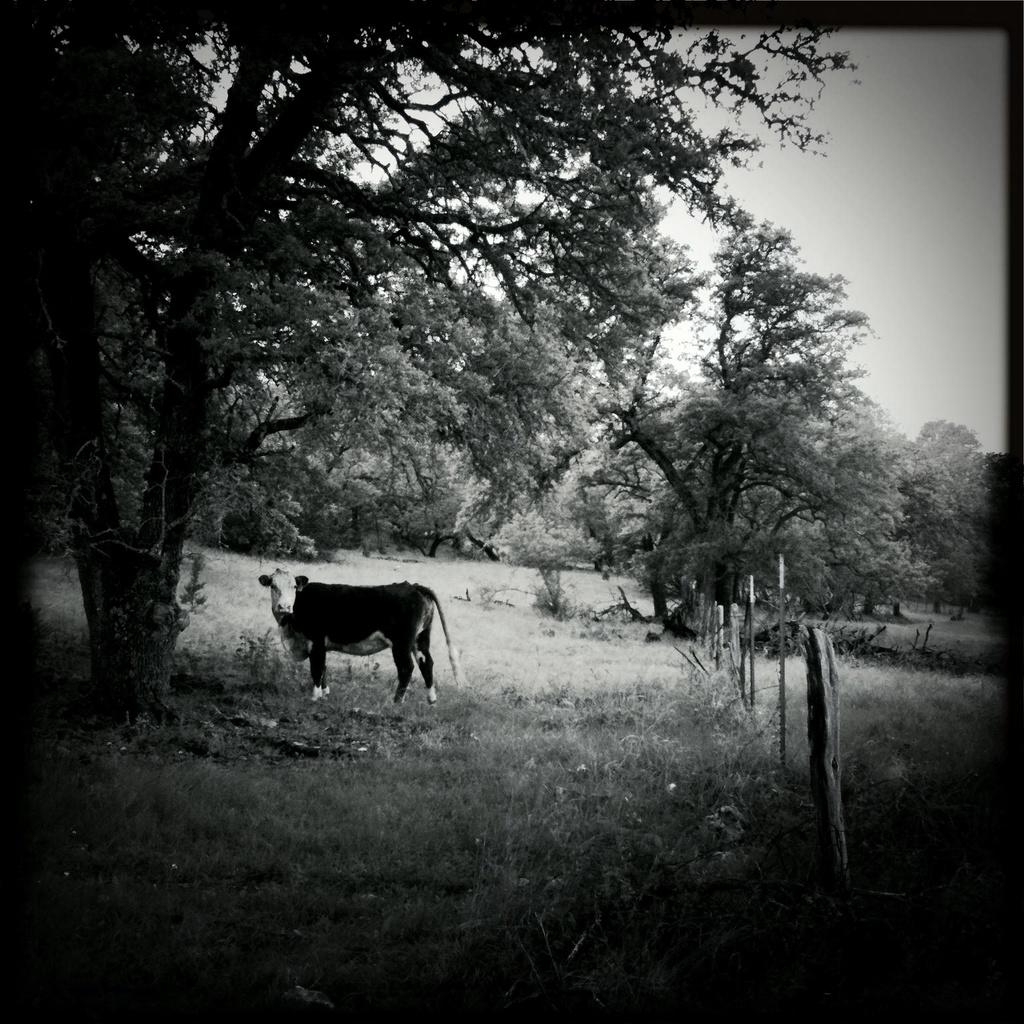What is the main subject in the center of the image? There is an animal in the center of the image. What type of natural environment is depicted in the image? There are trees in the image, which suggests a natural setting. What can be seen on the right side of the image? There is a fence on the right side of the image. What is visible in the background of the image? The sky is visible in the background of the image. What type of steel is used to construct the animal's smile in the image? There is no steel or smile present on the animal in the image. 